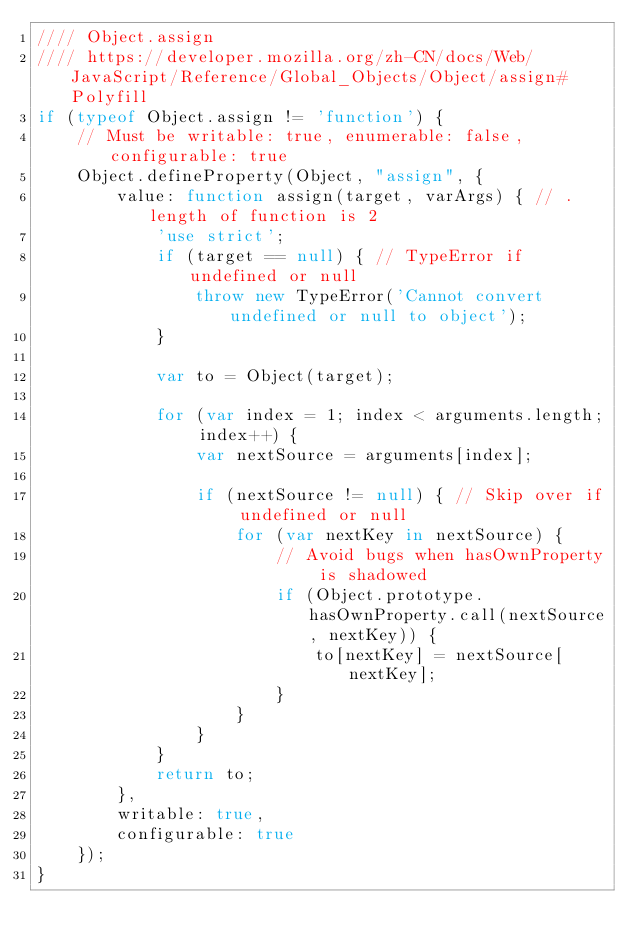<code> <loc_0><loc_0><loc_500><loc_500><_JavaScript_>//// Object.assign 
//// https://developer.mozilla.org/zh-CN/docs/Web/JavaScript/Reference/Global_Objects/Object/assign#Polyfill
if (typeof Object.assign != 'function') {
    // Must be writable: true, enumerable: false, configurable: true
    Object.defineProperty(Object, "assign", {
        value: function assign(target, varArgs) { // .length of function is 2
            'use strict';
            if (target == null) { // TypeError if undefined or null
                throw new TypeError('Cannot convert undefined or null to object');
            }

            var to = Object(target);

            for (var index = 1; index < arguments.length; index++) {
                var nextSource = arguments[index];

                if (nextSource != null) { // Skip over if undefined or null
                    for (var nextKey in nextSource) {
                        // Avoid bugs when hasOwnProperty is shadowed
                        if (Object.prototype.hasOwnProperty.call(nextSource, nextKey)) {
                            to[nextKey] = nextSource[nextKey];
                        }
                    }
                }
            }
            return to;
        },
        writable: true,
        configurable: true
    });
}</code> 